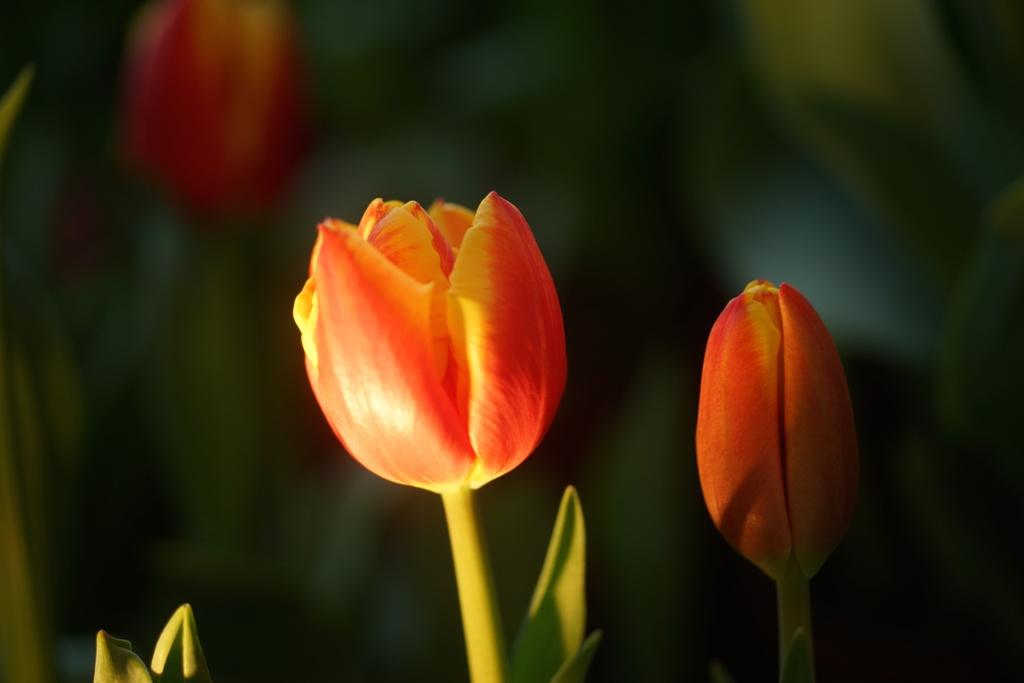What type of flowers are in the image? There are tulip flowers in the image. Can you describe the background of the image? The background of the image is blurred. What type of army is depicted in the image? There is no army present in the image; it features tulip flowers and a blurred background. What type of oven is visible in the image? There is no oven present in the image; it features tulip flowers and a blurred background. 